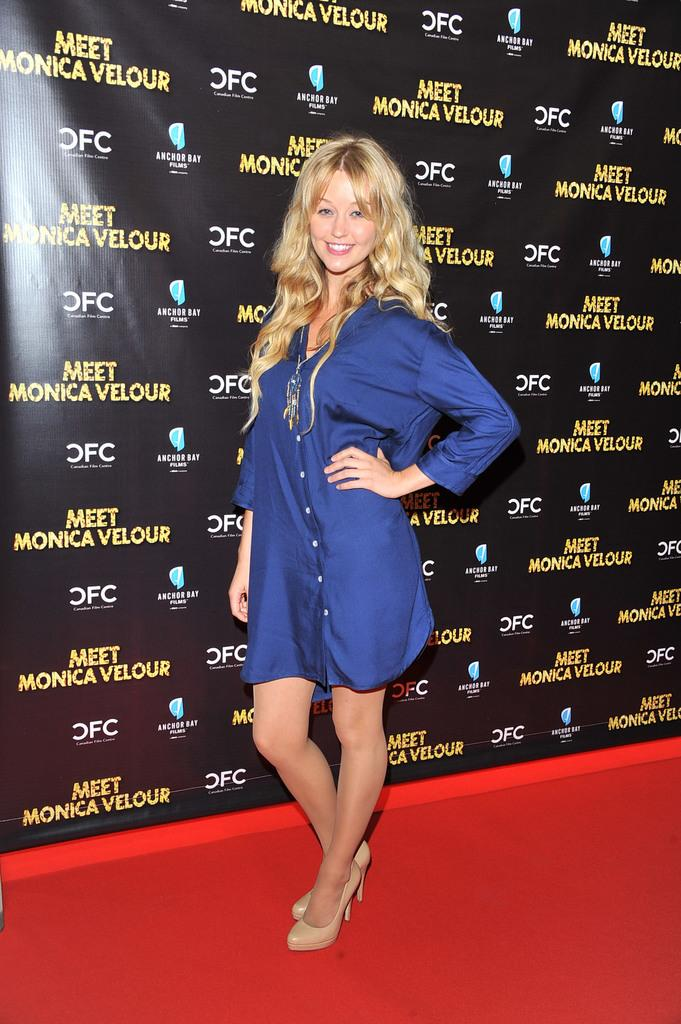What is the main subject of the image? There is a beautiful woman in the image. What is the woman doing in the image? The woman is standing. What is the woman wearing in the image? The woman is wearing a blue dress. What other object can be seen in the image? There is a banner in the image. What is the color of the banner? The banner is black in color. Can you tell me how many clouds are visible behind the woman in the image? There are no clouds visible in the image; it only shows a woman standing and a black banner. What type of zipper is featured on the woman's dress in the image? There is no zipper visible on the woman's dress in the image; it is a blue dress with no visible fasteners. 